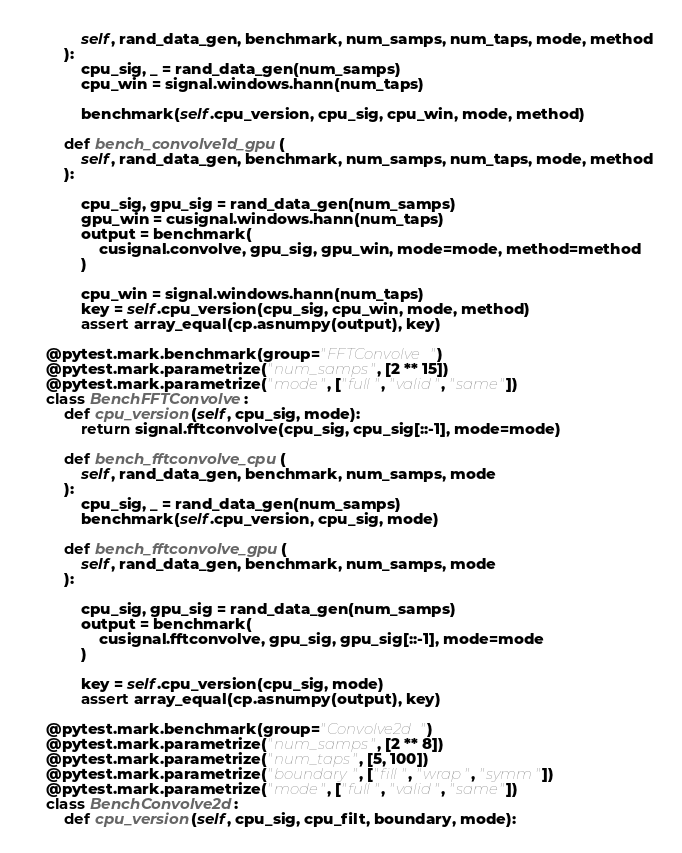<code> <loc_0><loc_0><loc_500><loc_500><_Python_>            self, rand_data_gen, benchmark, num_samps, num_taps, mode, method
        ):
            cpu_sig, _ = rand_data_gen(num_samps)
            cpu_win = signal.windows.hann(num_taps)

            benchmark(self.cpu_version, cpu_sig, cpu_win, mode, method)

        def bench_convolve1d_gpu(
            self, rand_data_gen, benchmark, num_samps, num_taps, mode, method
        ):

            cpu_sig, gpu_sig = rand_data_gen(num_samps)
            gpu_win = cusignal.windows.hann(num_taps)
            output = benchmark(
                cusignal.convolve, gpu_sig, gpu_win, mode=mode, method=method
            )

            cpu_win = signal.windows.hann(num_taps)
            key = self.cpu_version(cpu_sig, cpu_win, mode, method)
            assert array_equal(cp.asnumpy(output), key)

    @pytest.mark.benchmark(group="FFTConvolve")
    @pytest.mark.parametrize("num_samps", [2 ** 15])
    @pytest.mark.parametrize("mode", ["full", "valid", "same"])
    class BenchFFTConvolve:
        def cpu_version(self, cpu_sig, mode):
            return signal.fftconvolve(cpu_sig, cpu_sig[::-1], mode=mode)

        def bench_fftconvolve_cpu(
            self, rand_data_gen, benchmark, num_samps, mode
        ):
            cpu_sig, _ = rand_data_gen(num_samps)
            benchmark(self.cpu_version, cpu_sig, mode)

        def bench_fftconvolve_gpu(
            self, rand_data_gen, benchmark, num_samps, mode
        ):

            cpu_sig, gpu_sig = rand_data_gen(num_samps)
            output = benchmark(
                cusignal.fftconvolve, gpu_sig, gpu_sig[::-1], mode=mode
            )

            key = self.cpu_version(cpu_sig, mode)
            assert array_equal(cp.asnumpy(output), key)

    @pytest.mark.benchmark(group="Convolve2d")
    @pytest.mark.parametrize("num_samps", [2 ** 8])
    @pytest.mark.parametrize("num_taps", [5, 100])
    @pytest.mark.parametrize("boundary", ["fill", "wrap", "symm"])
    @pytest.mark.parametrize("mode", ["full", "valid", "same"])
    class BenchConvolve2d:
        def cpu_version(self, cpu_sig, cpu_filt, boundary, mode):</code> 